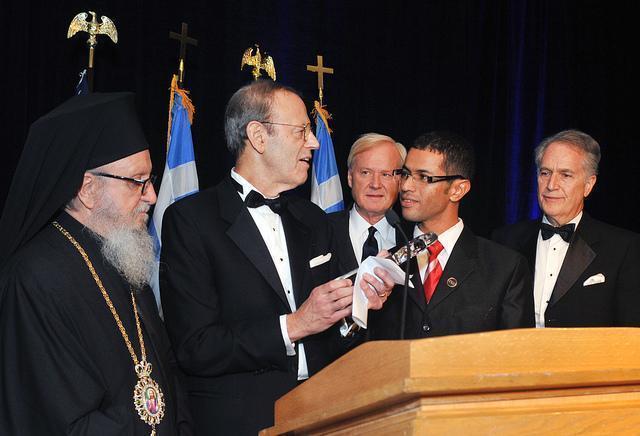The man on the left is probably a member of what type of group?
From the following four choices, select the correct answer to address the question.
Options: Politician, teacher, farmer, clergy. Clergy. 